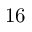Convert formula to latex. <formula><loc_0><loc_0><loc_500><loc_500>1 6</formula> 